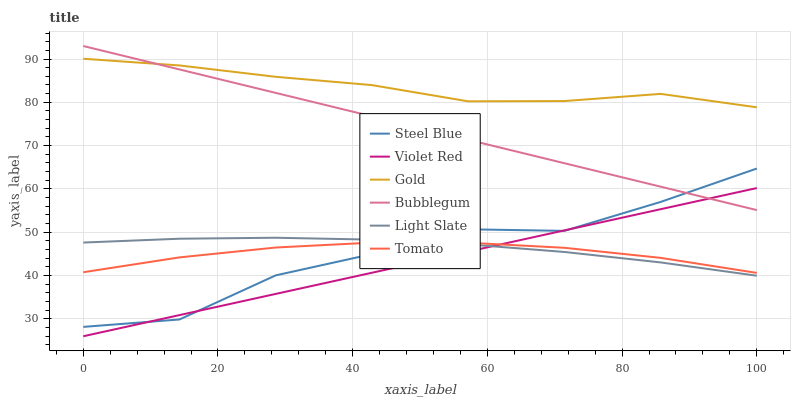Does Gold have the minimum area under the curve?
Answer yes or no. No. Does Violet Red have the maximum area under the curve?
Answer yes or no. No. Is Gold the smoothest?
Answer yes or no. No. Is Gold the roughest?
Answer yes or no. No. Does Gold have the lowest value?
Answer yes or no. No. Does Violet Red have the highest value?
Answer yes or no. No. Is Tomato less than Gold?
Answer yes or no. Yes. Is Bubblegum greater than Tomato?
Answer yes or no. Yes. Does Tomato intersect Gold?
Answer yes or no. No. 